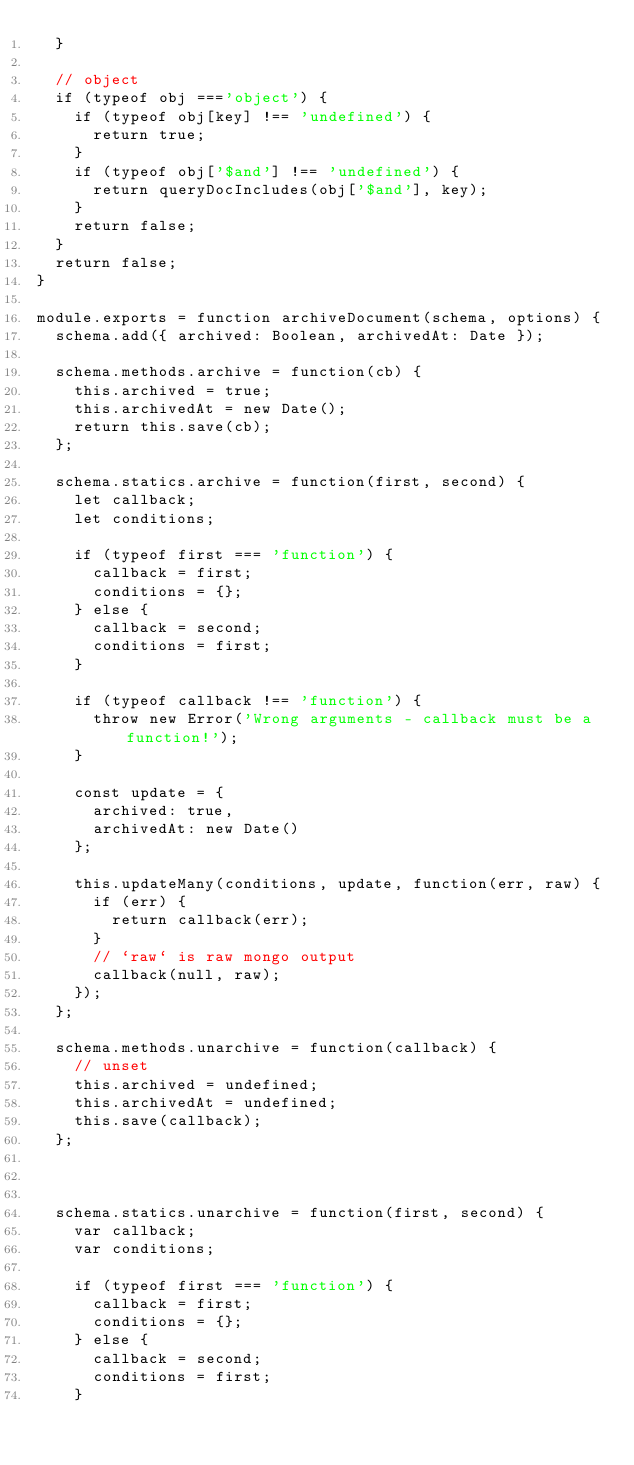<code> <loc_0><loc_0><loc_500><loc_500><_JavaScript_>  }

  // object
  if (typeof obj ==='object') {
    if (typeof obj[key] !== 'undefined') {
      return true;
    }
    if (typeof obj['$and'] !== 'undefined') {
      return queryDocIncludes(obj['$and'], key);
    }
    return false;
  }
  return false;
}

module.exports = function archiveDocument(schema, options) {
  schema.add({ archived: Boolean, archivedAt: Date });

  schema.methods.archive = function(cb) {
    this.archived = true;
    this.archivedAt = new Date();
    return this.save(cb);
  };

  schema.statics.archive = function(first, second) {
    let callback;
    let conditions;

    if (typeof first === 'function') {
      callback = first;
      conditions = {};
    } else {
      callback = second;
      conditions = first;
    }

    if (typeof callback !== 'function') {
      throw new Error('Wrong arguments - callback must be a function!');
    }

    const update = {
      archived: true,
      archivedAt: new Date()
    };

    this.updateMany(conditions, update, function(err, raw) {
      if (err) {
        return callback(err);
      }
      // `raw` is raw mongo output
      callback(null, raw);
    });
  };

  schema.methods.unarchive = function(callback) {
    // unset
    this.archived = undefined;
    this.archivedAt = undefined;
    this.save(callback);
  };
  


  schema.statics.unarchive = function(first, second) {
    var callback;
    var conditions;

    if (typeof first === 'function') {
      callback = first;
      conditions = {};
    } else {
      callback = second;
      conditions = first;
    }
</code> 